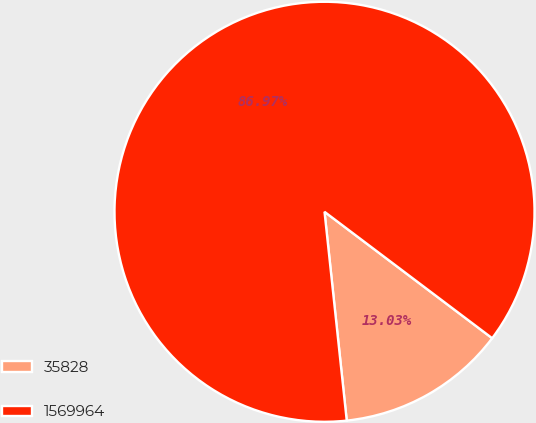Convert chart to OTSL. <chart><loc_0><loc_0><loc_500><loc_500><pie_chart><fcel>35828<fcel>1569964<nl><fcel>13.03%<fcel>86.97%<nl></chart> 